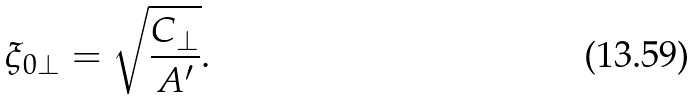Convert formula to latex. <formula><loc_0><loc_0><loc_500><loc_500>\xi _ { 0 \perp } = \sqrt { \frac { C _ { \perp } } { A ^ { \prime } } } .</formula> 